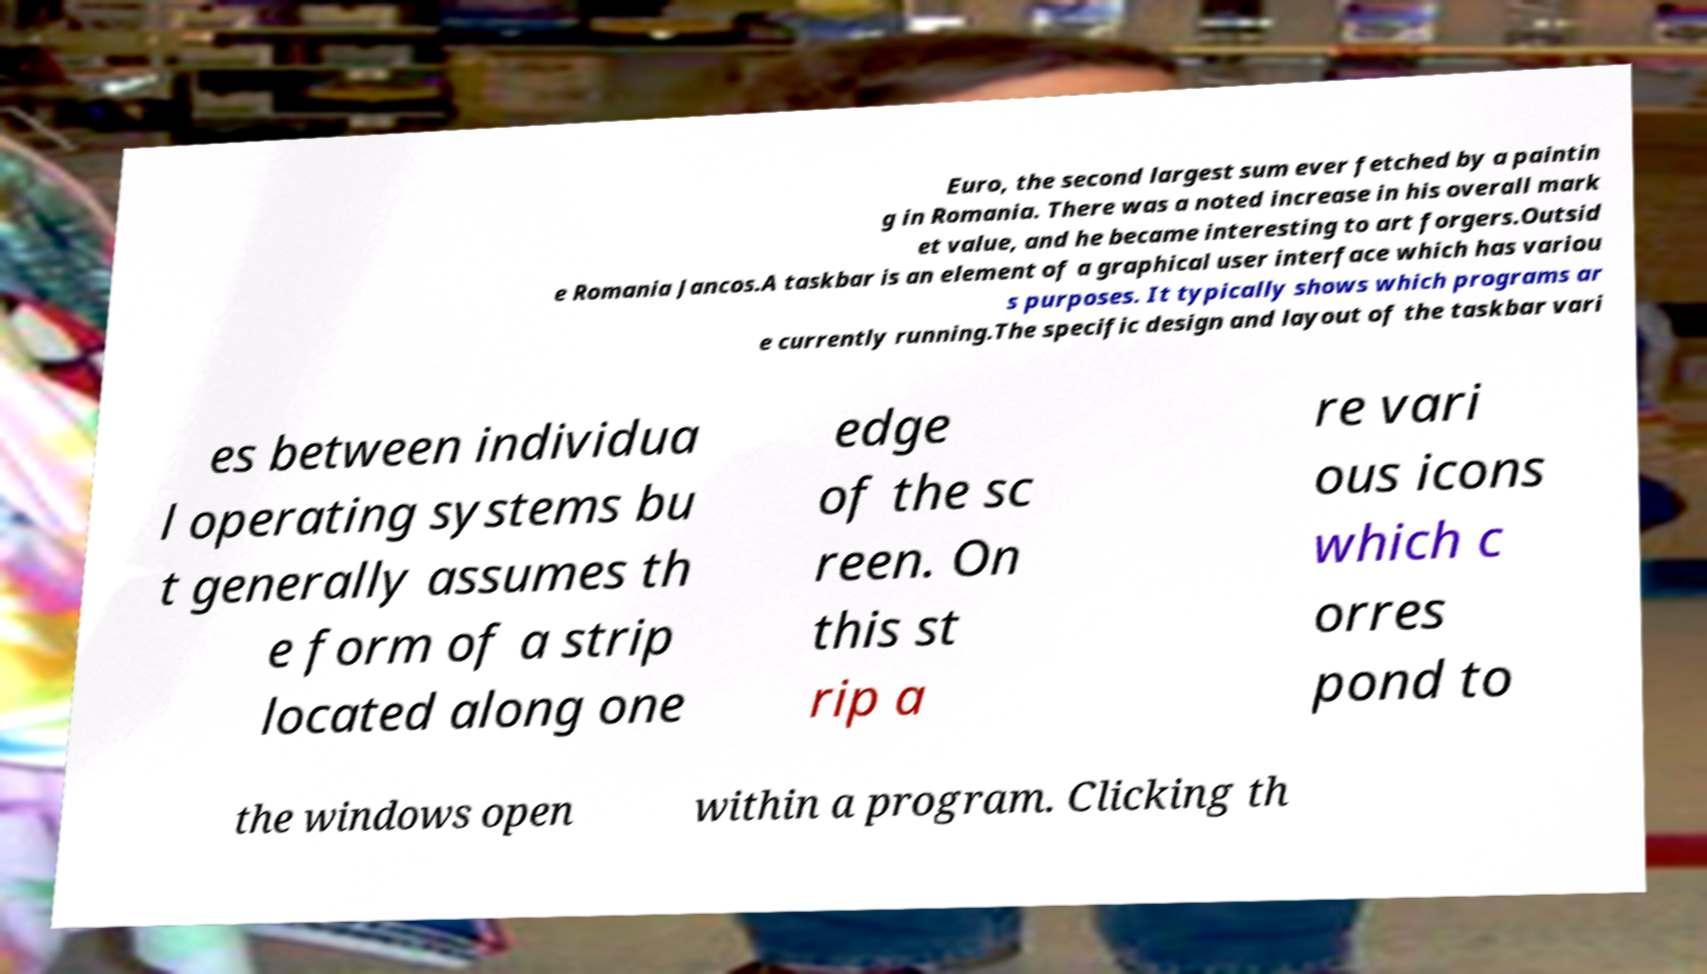What messages or text are displayed in this image? I need them in a readable, typed format. Euro, the second largest sum ever fetched by a paintin g in Romania. There was a noted increase in his overall mark et value, and he became interesting to art forgers.Outsid e Romania Jancos.A taskbar is an element of a graphical user interface which has variou s purposes. It typically shows which programs ar e currently running.The specific design and layout of the taskbar vari es between individua l operating systems bu t generally assumes th e form of a strip located along one edge of the sc reen. On this st rip a re vari ous icons which c orres pond to the windows open within a program. Clicking th 